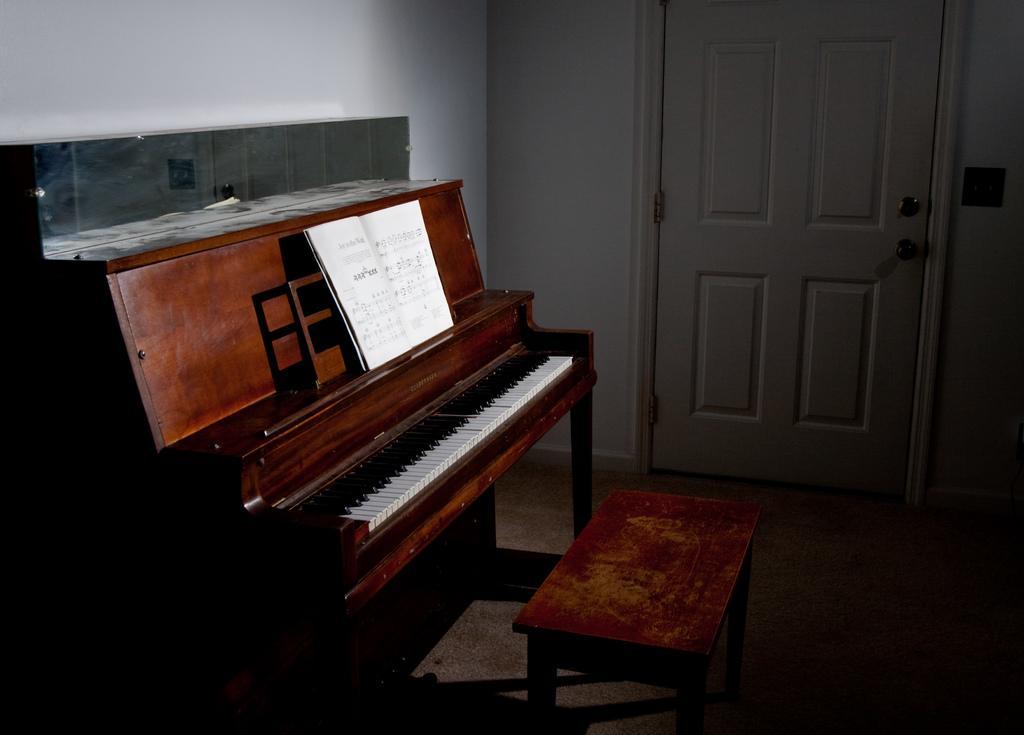Can you describe this image briefly? In this picture we can see a room with piano and on piano we have musical note book and aside to this we have a table and in background we can see wall, door. 